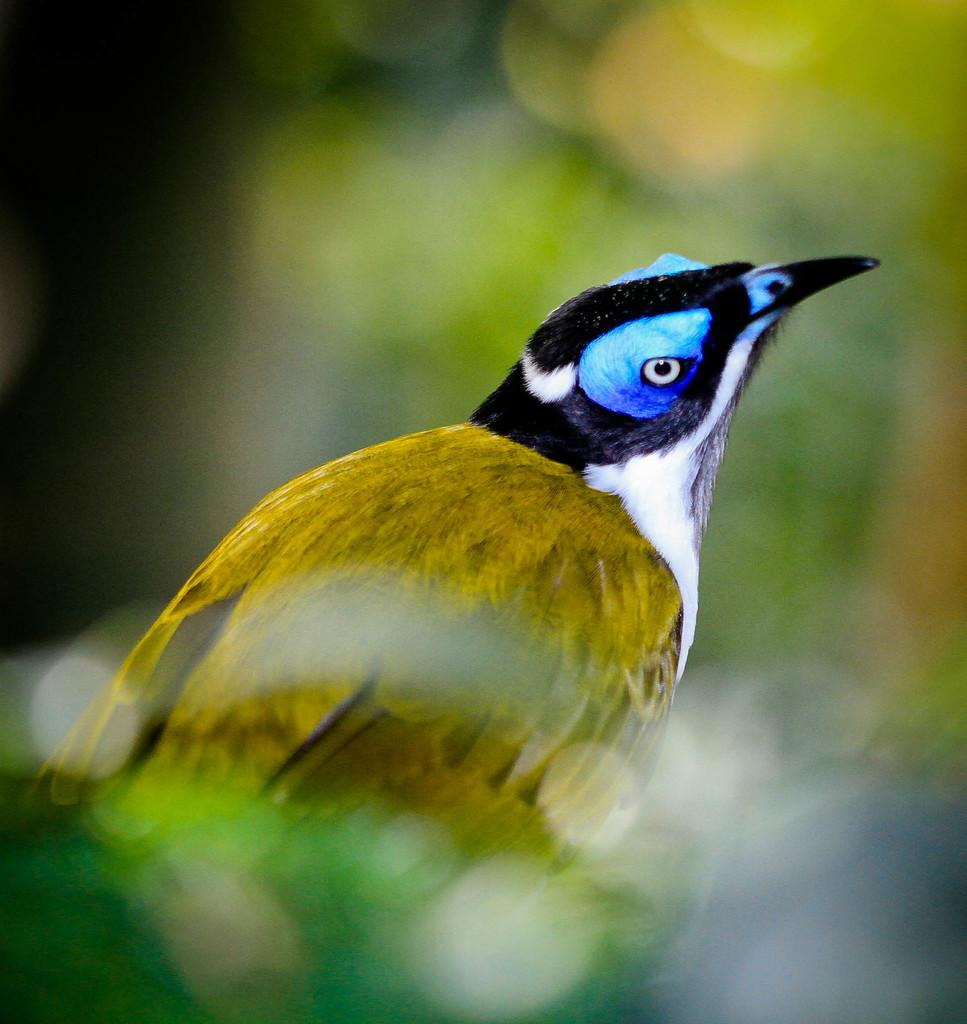What is the main subject in the center of the image? There is a bird in the center of the image. What type of leaf can be seen in the image? There is no leaf present in the image; it features a bird in the center. How many monkeys are visible in the image? There are no monkeys present in the image; it features a bird in the center. 